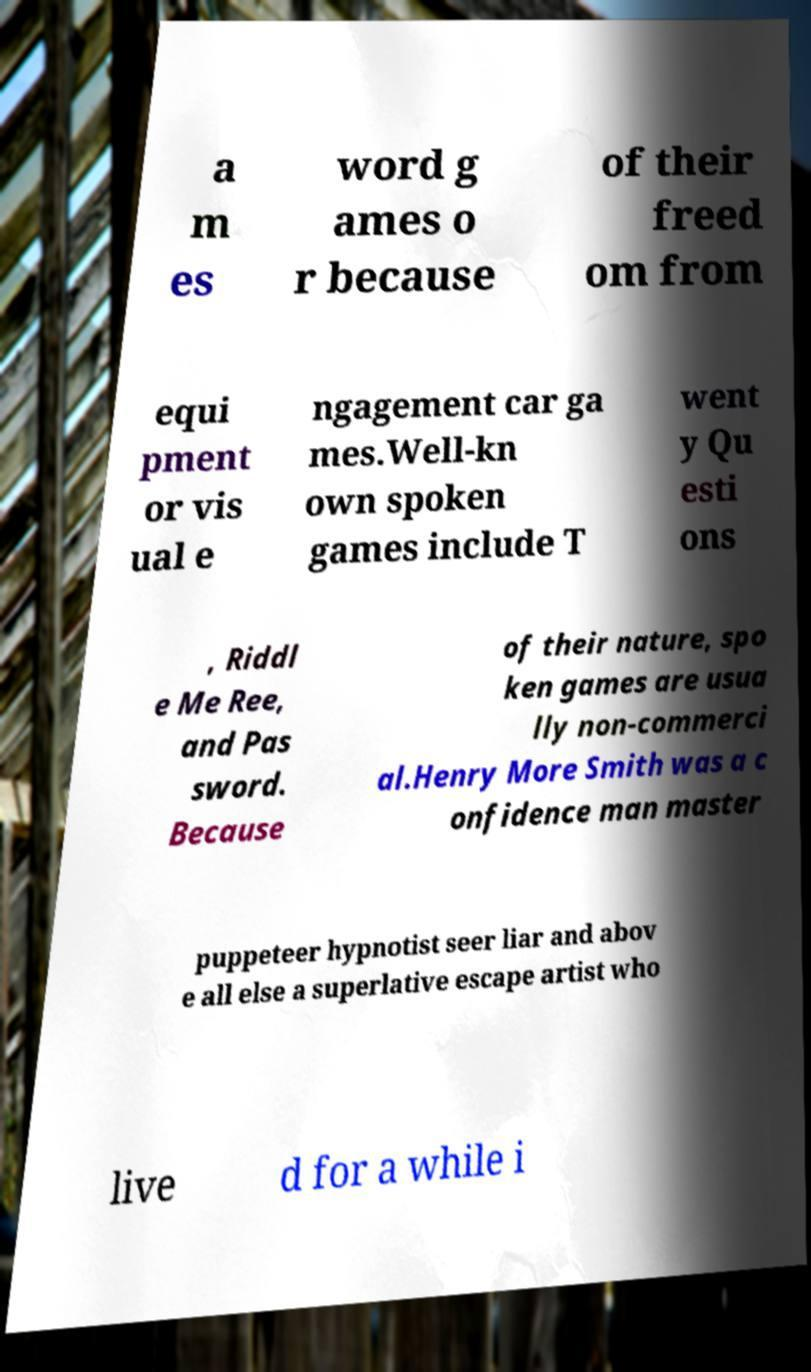Please read and relay the text visible in this image. What does it say? a m es word g ames o r because of their freed om from equi pment or vis ual e ngagement car ga mes.Well-kn own spoken games include T went y Qu esti ons , Riddl e Me Ree, and Pas sword. Because of their nature, spo ken games are usua lly non-commerci al.Henry More Smith was a c onfidence man master puppeteer hypnotist seer liar and abov e all else a superlative escape artist who live d for a while i 